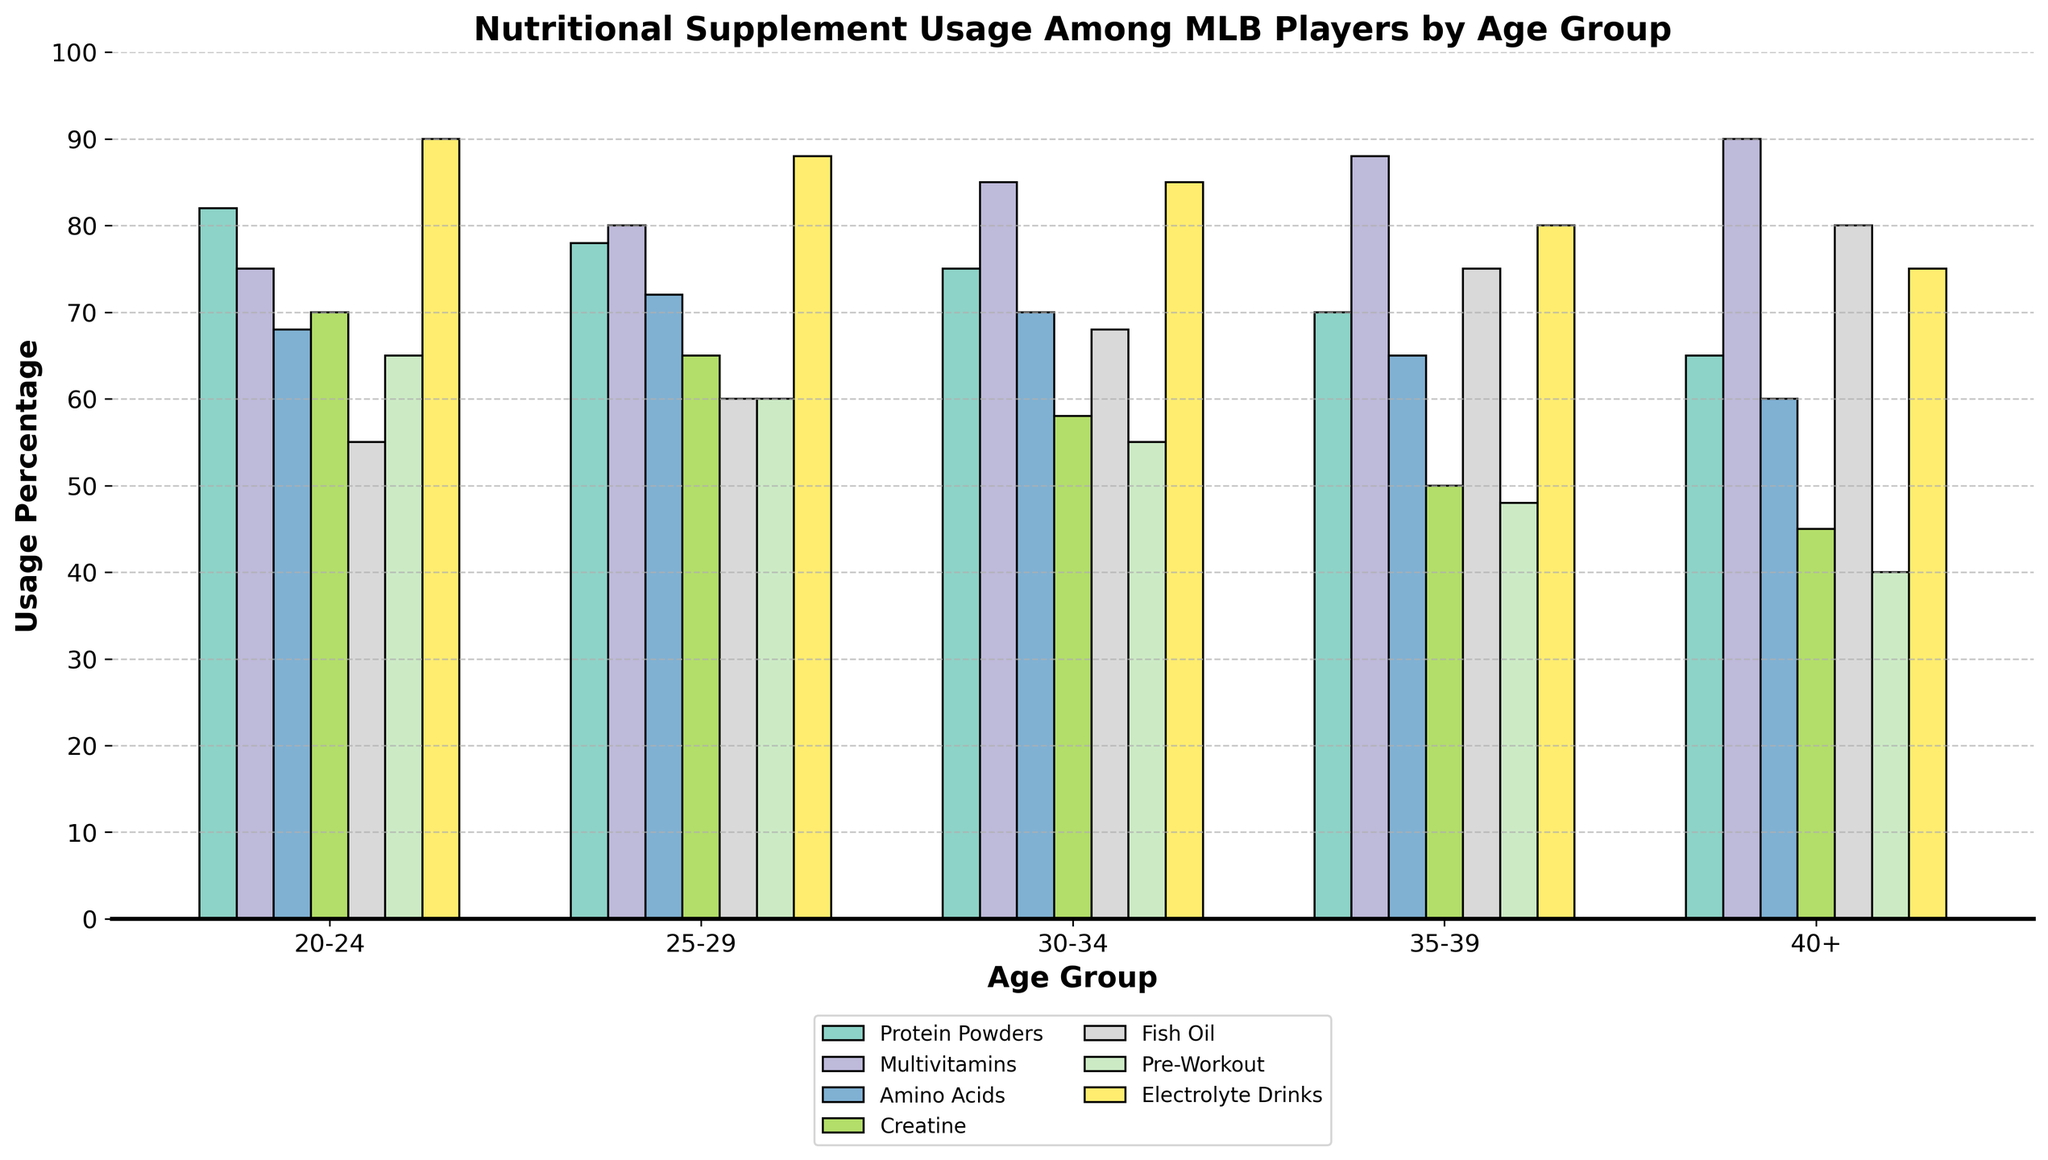What's the most commonly used supplement among the 20-24 age group? Check the bar representing the 20-24 age group and identify the tallest bar which indicates the highest usage percentage.
Answer: Electrolyte Drinks Which age group has the highest usage of fish oil? Compare the heights of the bars representing fish oil across all age groups. The tallest bar indicates the highest usage.
Answer: 40+ What is the difference in creatine usage between the 25-29 age group and the 35-39 age group? Refer to the bars representing creatine usage for the 25-29 and 35-39 age groups. Calculate the difference: 65% - 50% = 15%.
Answer: 15% Which two age groups have the closest usage percentage for amino acids? Look at the bars representing amino acids for each age group and find the two with the smallest difference in height. The two age groups with closest usage are 20-24 (68%) and 30-34 (70%).
Answer: 20-24 and 30-34 What's the average usage percentage of multivitamins across all age groups? Sum the percentages of multivitamin usage across all age groups and divide by the number of age groups: (75% + 80% + 85% + 88% + 90%) ÷ 5 = 83.6%.
Answer: 83.6% Does the usage of protein powders increase or decrease with age? Observe the trend of the bars representing protein powders from the youngest to the oldest age group. The height of the bars seems to decrease.
Answer: Decrease Which supplement has a consistently increasing usage trend with age? Analyze the trend of each supplement across age groups. Fish oil shows a consistent increase.
Answer: Fish Oil How does the usage of pre-workout supplements compare between the youngest and oldest age groups? Check the bars representing pre-workout supplements for the 20-24 and 40+ age groups and compare their heights: 65% for 20-24 and 40% for 40+. The usage decreases.
Answer: Decreases Among the 30-34 age group, which two supplements have equal usage percentages? Look at the bars representing the 30-34 age group to identify the supplements with equal heights. Amino Acids and Electrolyte Drinks both have a usage of 70%.
Answer: Amino Acids and Electrolyte Drinks What is the total usage percentage of all supplements for the 35-39 age group? Sum the usage percentages of all supplements for the 35-39 age group: 70% + 88% + 65% + 50% + 75% + 48% + 80% = 476%.
Answer: 476% 